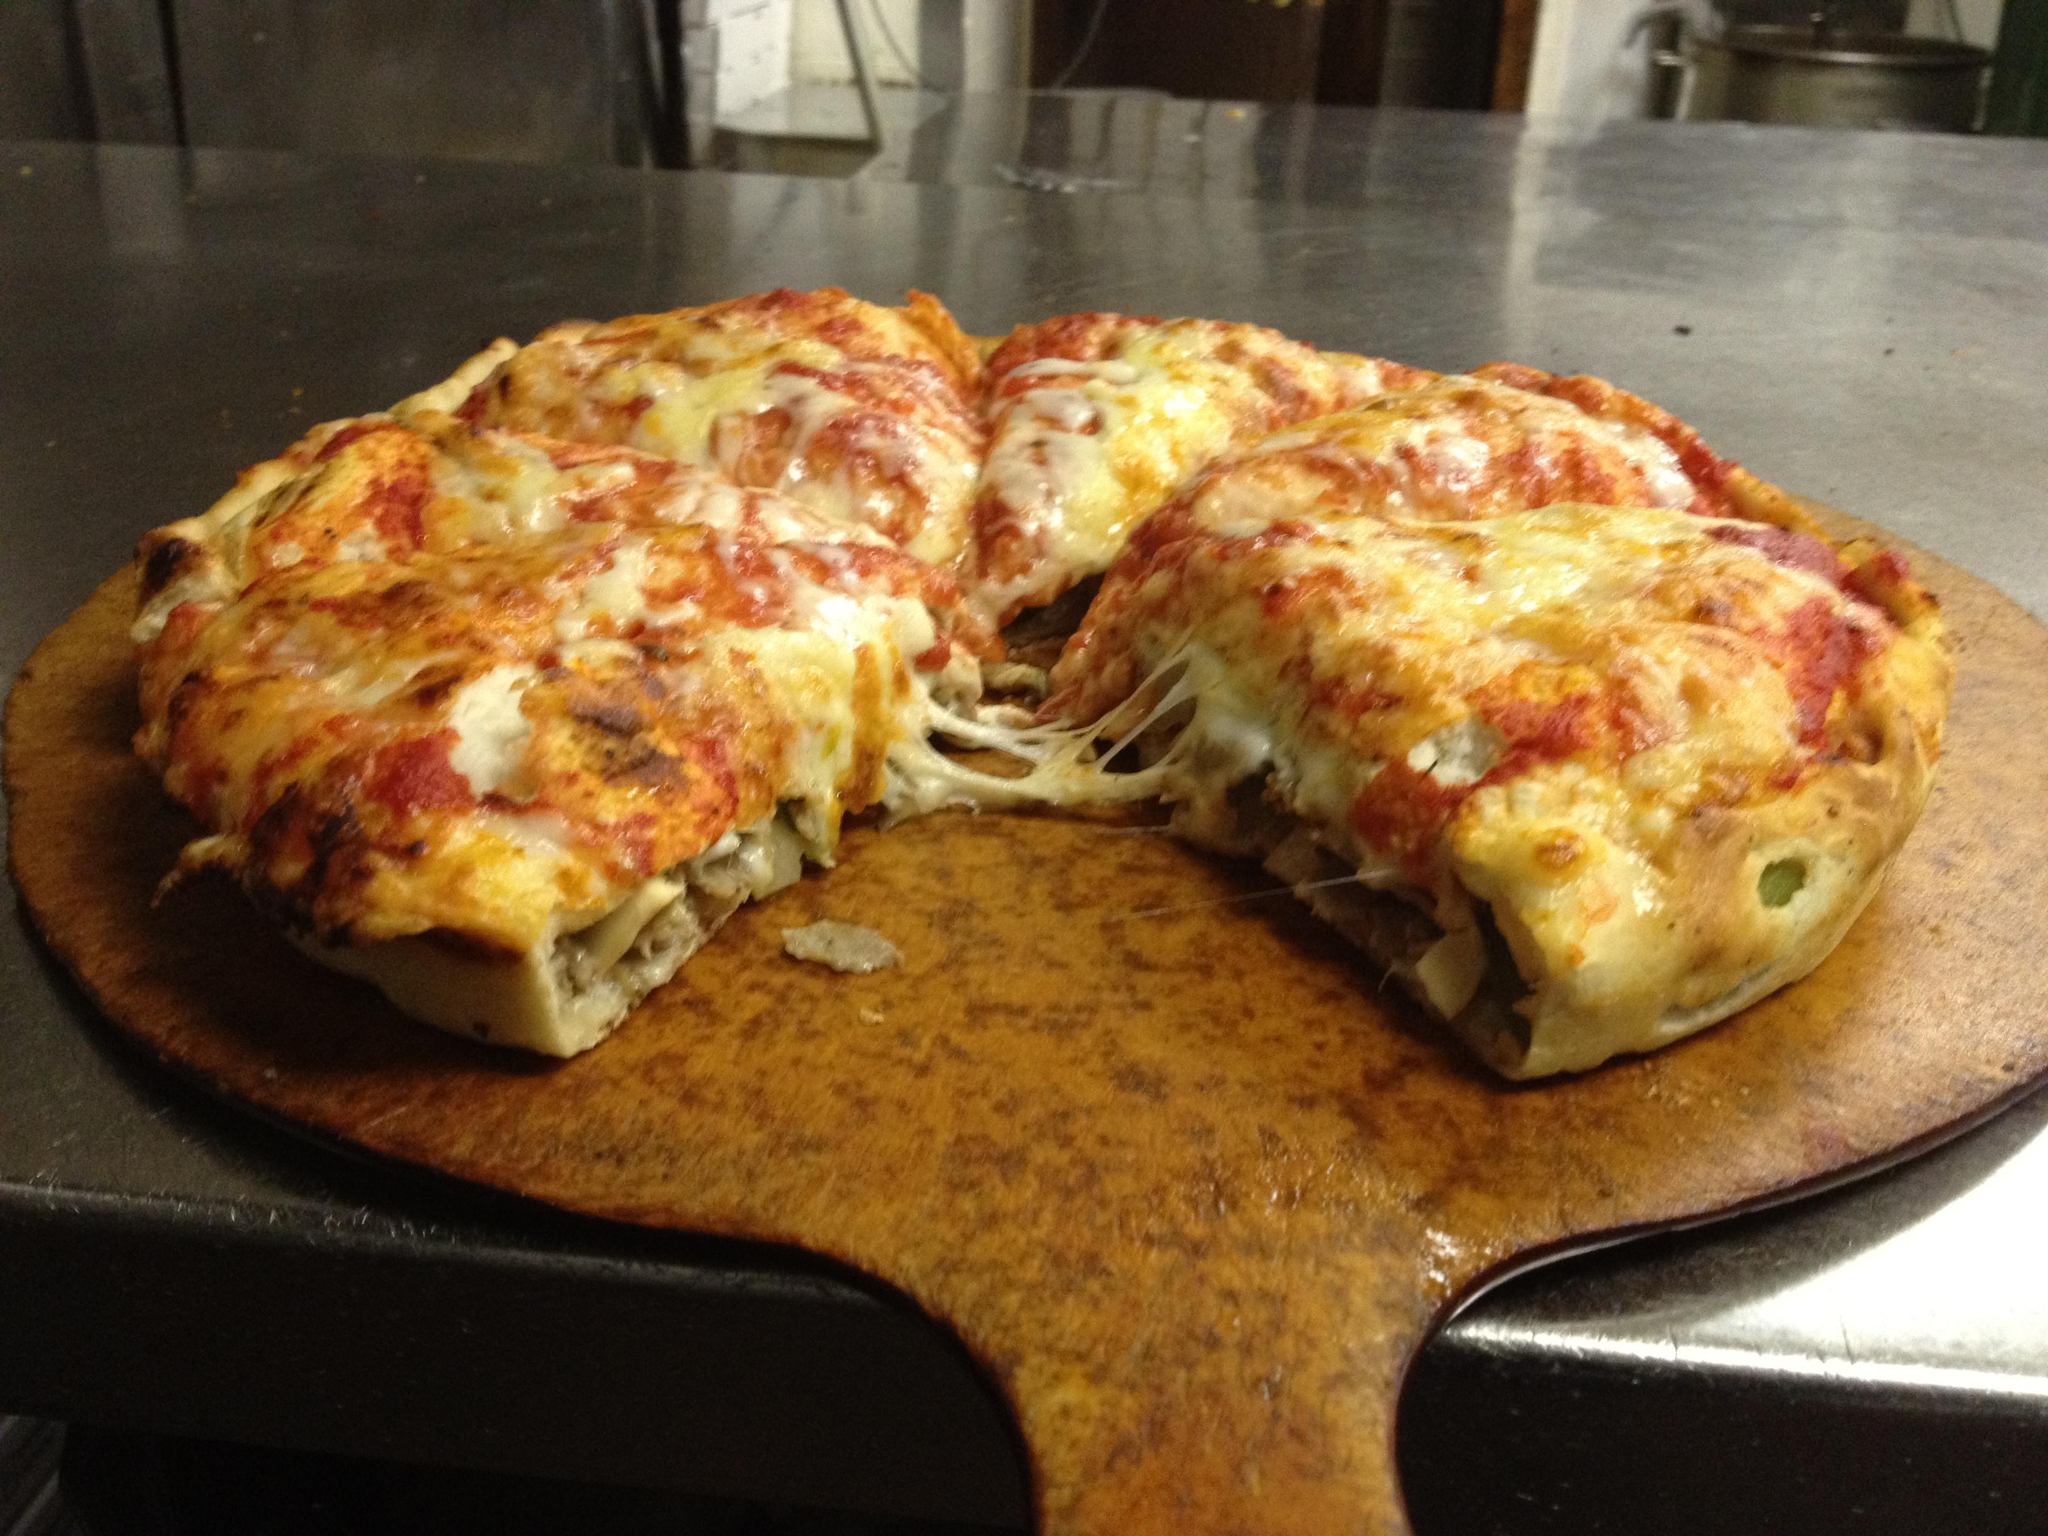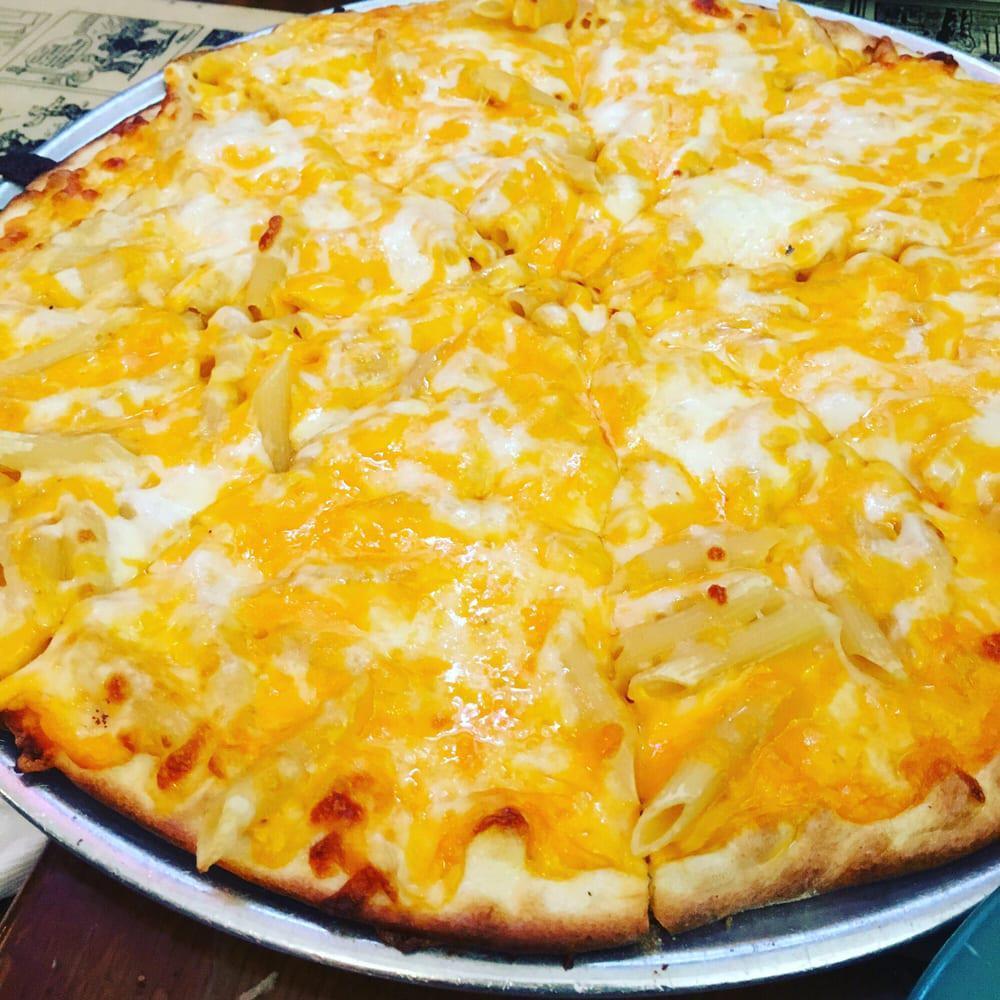The first image is the image on the left, the second image is the image on the right. Analyze the images presented: Is the assertion "The pizza in one of the images sits directly on a wooden paddle." valid? Answer yes or no. Yes. The first image is the image on the left, the second image is the image on the right. Considering the images on both sides, is "There are two full circle pizzas." valid? Answer yes or no. No. 